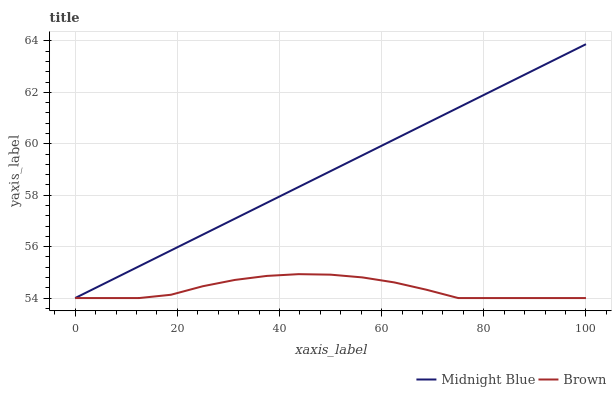Does Brown have the minimum area under the curve?
Answer yes or no. Yes. Does Midnight Blue have the maximum area under the curve?
Answer yes or no. Yes. Does Midnight Blue have the minimum area under the curve?
Answer yes or no. No. Is Midnight Blue the smoothest?
Answer yes or no. Yes. Is Brown the roughest?
Answer yes or no. Yes. Is Midnight Blue the roughest?
Answer yes or no. No. Does Brown have the lowest value?
Answer yes or no. Yes. Does Midnight Blue have the highest value?
Answer yes or no. Yes. Does Midnight Blue intersect Brown?
Answer yes or no. Yes. Is Midnight Blue less than Brown?
Answer yes or no. No. Is Midnight Blue greater than Brown?
Answer yes or no. No. 